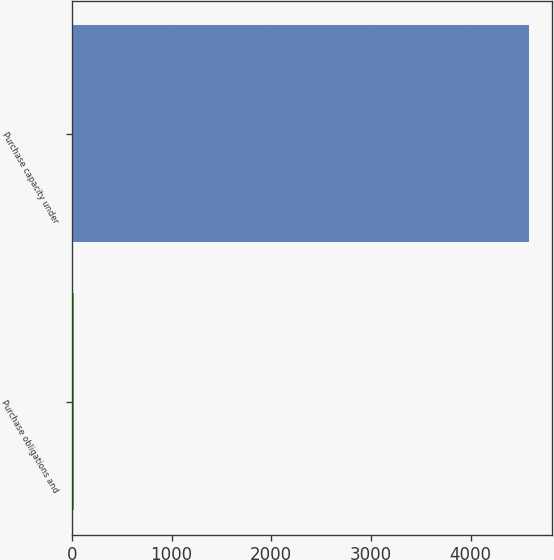Convert chart to OTSL. <chart><loc_0><loc_0><loc_500><loc_500><bar_chart><fcel>Purchase obligations and<fcel>Purchase capacity under<nl><fcel>18<fcel>4588<nl></chart> 